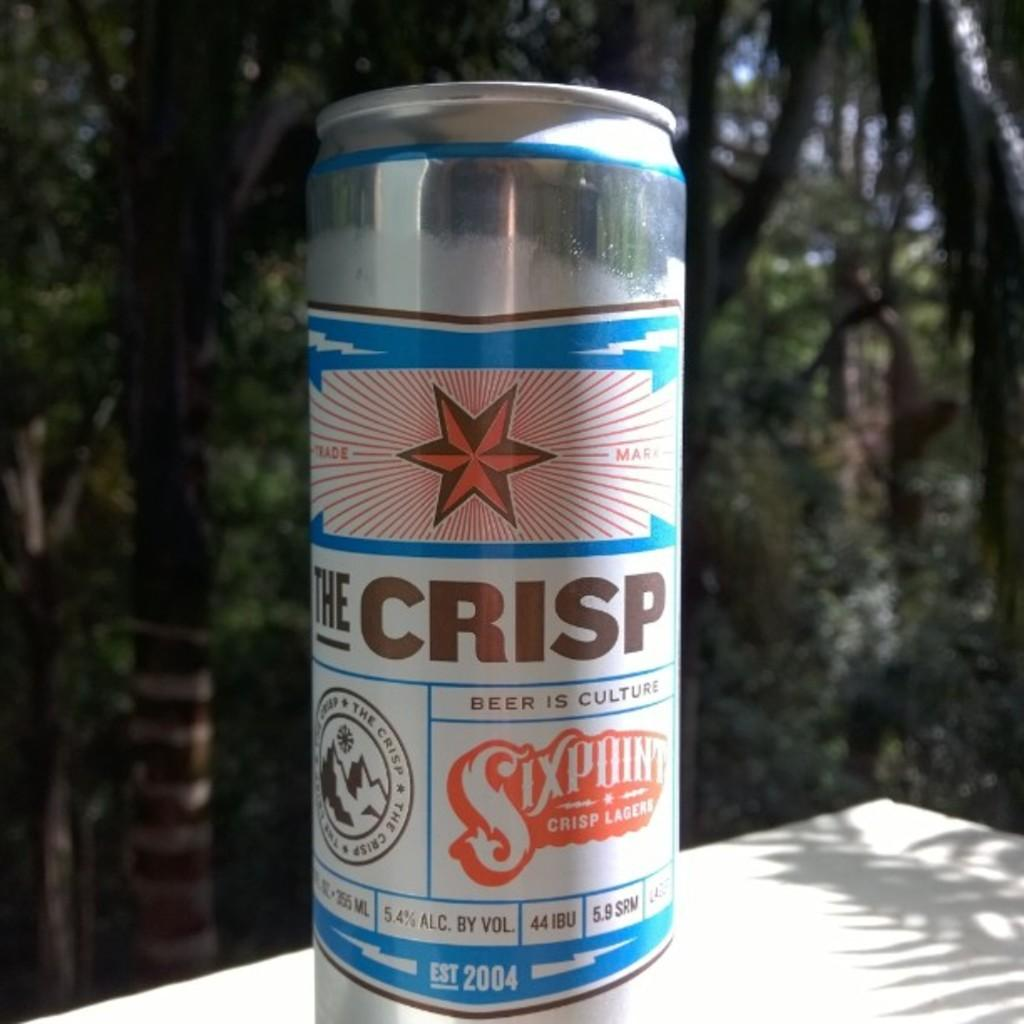<image>
Present a compact description of the photo's key features. A beer can is outside in the sun and has the slogan "Beer is Culture". 